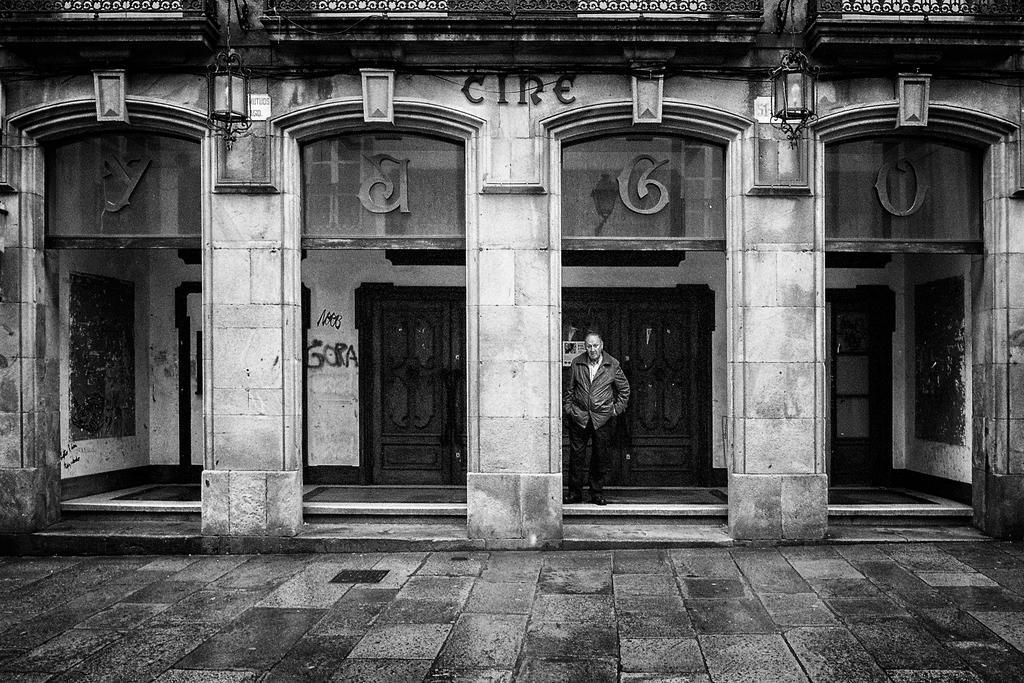Describe this image in one or two sentences. In this picture we can see a building, there is a man standing here, we can see doors here. 